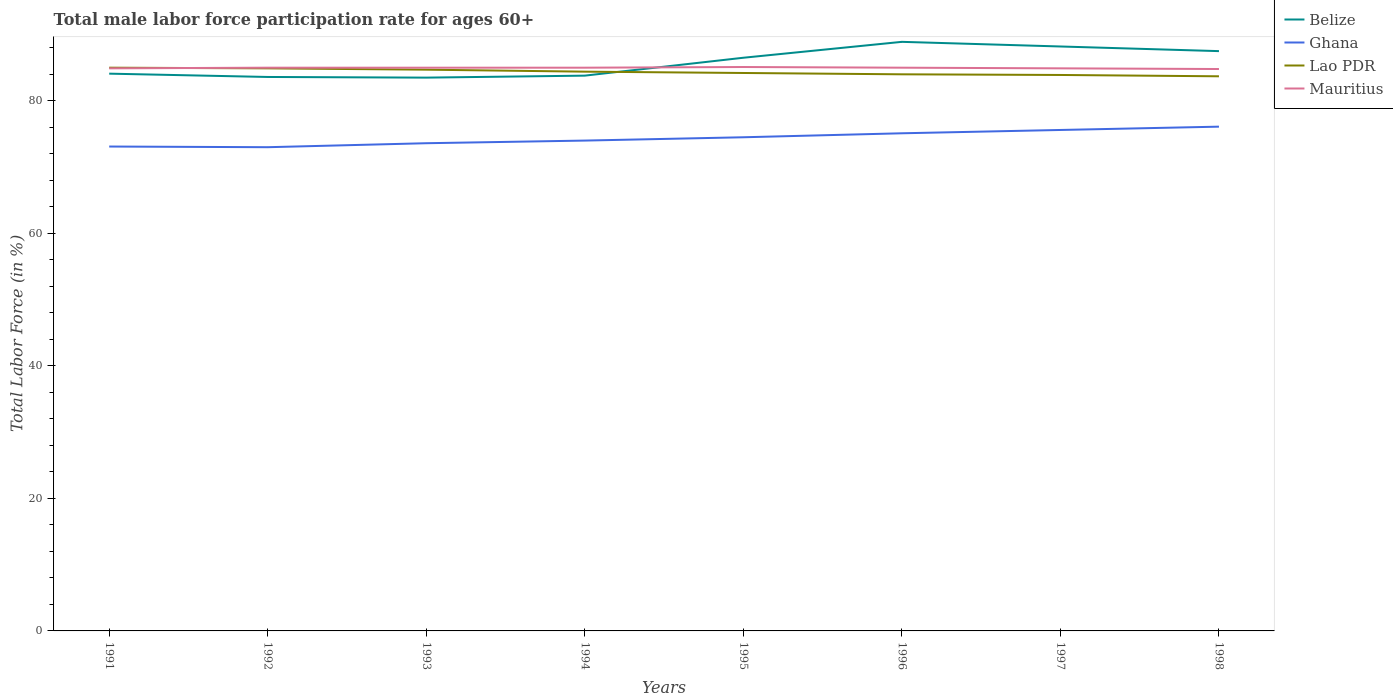Is the number of lines equal to the number of legend labels?
Your answer should be compact. Yes. Across all years, what is the maximum male labor force participation rate in Belize?
Make the answer very short. 83.5. What is the total male labor force participation rate in Ghana in the graph?
Provide a succinct answer. -2.5. What is the difference between the highest and the second highest male labor force participation rate in Ghana?
Make the answer very short. 3.1. Is the male labor force participation rate in Mauritius strictly greater than the male labor force participation rate in Ghana over the years?
Offer a terse response. No. How many years are there in the graph?
Ensure brevity in your answer.  8. What is the difference between two consecutive major ticks on the Y-axis?
Provide a succinct answer. 20. Are the values on the major ticks of Y-axis written in scientific E-notation?
Provide a short and direct response. No. Where does the legend appear in the graph?
Keep it short and to the point. Top right. How many legend labels are there?
Your answer should be compact. 4. How are the legend labels stacked?
Your answer should be very brief. Vertical. What is the title of the graph?
Provide a succinct answer. Total male labor force participation rate for ages 60+. What is the label or title of the X-axis?
Provide a succinct answer. Years. What is the label or title of the Y-axis?
Your answer should be very brief. Total Labor Force (in %). What is the Total Labor Force (in %) in Belize in 1991?
Your answer should be compact. 84.1. What is the Total Labor Force (in %) of Ghana in 1991?
Offer a very short reply. 73.1. What is the Total Labor Force (in %) in Mauritius in 1991?
Make the answer very short. 84.9. What is the Total Labor Force (in %) in Belize in 1992?
Keep it short and to the point. 83.6. What is the Total Labor Force (in %) in Ghana in 1992?
Your answer should be very brief. 73. What is the Total Labor Force (in %) in Lao PDR in 1992?
Give a very brief answer. 84.9. What is the Total Labor Force (in %) of Mauritius in 1992?
Keep it short and to the point. 85. What is the Total Labor Force (in %) of Belize in 1993?
Offer a terse response. 83.5. What is the Total Labor Force (in %) in Ghana in 1993?
Keep it short and to the point. 73.6. What is the Total Labor Force (in %) of Lao PDR in 1993?
Give a very brief answer. 84.7. What is the Total Labor Force (in %) of Belize in 1994?
Your response must be concise. 83.8. What is the Total Labor Force (in %) in Ghana in 1994?
Your response must be concise. 74. What is the Total Labor Force (in %) of Lao PDR in 1994?
Your answer should be compact. 84.4. What is the Total Labor Force (in %) of Belize in 1995?
Your answer should be very brief. 86.5. What is the Total Labor Force (in %) of Ghana in 1995?
Offer a very short reply. 74.5. What is the Total Labor Force (in %) of Lao PDR in 1995?
Make the answer very short. 84.2. What is the Total Labor Force (in %) of Mauritius in 1995?
Make the answer very short. 85.1. What is the Total Labor Force (in %) in Belize in 1996?
Your response must be concise. 88.9. What is the Total Labor Force (in %) of Ghana in 1996?
Keep it short and to the point. 75.1. What is the Total Labor Force (in %) of Mauritius in 1996?
Ensure brevity in your answer.  85. What is the Total Labor Force (in %) in Belize in 1997?
Provide a short and direct response. 88.2. What is the Total Labor Force (in %) in Ghana in 1997?
Your response must be concise. 75.6. What is the Total Labor Force (in %) in Lao PDR in 1997?
Give a very brief answer. 83.9. What is the Total Labor Force (in %) in Mauritius in 1997?
Provide a succinct answer. 84.9. What is the Total Labor Force (in %) of Belize in 1998?
Offer a terse response. 87.5. What is the Total Labor Force (in %) in Ghana in 1998?
Ensure brevity in your answer.  76.1. What is the Total Labor Force (in %) in Lao PDR in 1998?
Give a very brief answer. 83.7. What is the Total Labor Force (in %) of Mauritius in 1998?
Your response must be concise. 84.8. Across all years, what is the maximum Total Labor Force (in %) of Belize?
Provide a short and direct response. 88.9. Across all years, what is the maximum Total Labor Force (in %) in Ghana?
Provide a short and direct response. 76.1. Across all years, what is the maximum Total Labor Force (in %) of Mauritius?
Your answer should be very brief. 85.1. Across all years, what is the minimum Total Labor Force (in %) of Belize?
Your response must be concise. 83.5. Across all years, what is the minimum Total Labor Force (in %) in Lao PDR?
Offer a terse response. 83.7. Across all years, what is the minimum Total Labor Force (in %) of Mauritius?
Ensure brevity in your answer.  84.8. What is the total Total Labor Force (in %) in Belize in the graph?
Offer a terse response. 686.1. What is the total Total Labor Force (in %) in Ghana in the graph?
Provide a short and direct response. 595. What is the total Total Labor Force (in %) in Lao PDR in the graph?
Your answer should be compact. 674.8. What is the total Total Labor Force (in %) in Mauritius in the graph?
Provide a short and direct response. 679.7. What is the difference between the Total Labor Force (in %) of Belize in 1991 and that in 1992?
Keep it short and to the point. 0.5. What is the difference between the Total Labor Force (in %) of Ghana in 1991 and that in 1992?
Ensure brevity in your answer.  0.1. What is the difference between the Total Labor Force (in %) in Lao PDR in 1991 and that in 1992?
Offer a very short reply. 0.1. What is the difference between the Total Labor Force (in %) in Mauritius in 1991 and that in 1993?
Make the answer very short. -0.1. What is the difference between the Total Labor Force (in %) of Belize in 1991 and that in 1994?
Ensure brevity in your answer.  0.3. What is the difference between the Total Labor Force (in %) of Ghana in 1991 and that in 1994?
Give a very brief answer. -0.9. What is the difference between the Total Labor Force (in %) in Lao PDR in 1991 and that in 1994?
Your answer should be compact. 0.6. What is the difference between the Total Labor Force (in %) of Mauritius in 1991 and that in 1994?
Your answer should be very brief. -0.1. What is the difference between the Total Labor Force (in %) in Belize in 1991 and that in 1995?
Keep it short and to the point. -2.4. What is the difference between the Total Labor Force (in %) in Ghana in 1991 and that in 1995?
Give a very brief answer. -1.4. What is the difference between the Total Labor Force (in %) of Lao PDR in 1991 and that in 1995?
Your answer should be compact. 0.8. What is the difference between the Total Labor Force (in %) in Belize in 1991 and that in 1996?
Make the answer very short. -4.8. What is the difference between the Total Labor Force (in %) in Mauritius in 1991 and that in 1996?
Your answer should be compact. -0.1. What is the difference between the Total Labor Force (in %) of Ghana in 1991 and that in 1997?
Offer a very short reply. -2.5. What is the difference between the Total Labor Force (in %) in Lao PDR in 1991 and that in 1997?
Keep it short and to the point. 1.1. What is the difference between the Total Labor Force (in %) in Mauritius in 1991 and that in 1997?
Your answer should be compact. 0. What is the difference between the Total Labor Force (in %) of Belize in 1991 and that in 1998?
Ensure brevity in your answer.  -3.4. What is the difference between the Total Labor Force (in %) of Ghana in 1991 and that in 1998?
Your answer should be compact. -3. What is the difference between the Total Labor Force (in %) in Mauritius in 1991 and that in 1998?
Your answer should be compact. 0.1. What is the difference between the Total Labor Force (in %) of Belize in 1992 and that in 1993?
Provide a succinct answer. 0.1. What is the difference between the Total Labor Force (in %) in Mauritius in 1992 and that in 1993?
Ensure brevity in your answer.  0. What is the difference between the Total Labor Force (in %) in Belize in 1992 and that in 1994?
Provide a succinct answer. -0.2. What is the difference between the Total Labor Force (in %) of Lao PDR in 1992 and that in 1994?
Your response must be concise. 0.5. What is the difference between the Total Labor Force (in %) of Mauritius in 1992 and that in 1994?
Your answer should be compact. 0. What is the difference between the Total Labor Force (in %) in Belize in 1992 and that in 1995?
Provide a succinct answer. -2.9. What is the difference between the Total Labor Force (in %) in Ghana in 1992 and that in 1995?
Offer a terse response. -1.5. What is the difference between the Total Labor Force (in %) of Lao PDR in 1992 and that in 1995?
Your answer should be compact. 0.7. What is the difference between the Total Labor Force (in %) in Ghana in 1992 and that in 1996?
Ensure brevity in your answer.  -2.1. What is the difference between the Total Labor Force (in %) in Mauritius in 1992 and that in 1996?
Ensure brevity in your answer.  0. What is the difference between the Total Labor Force (in %) in Ghana in 1992 and that in 1997?
Ensure brevity in your answer.  -2.6. What is the difference between the Total Labor Force (in %) of Mauritius in 1992 and that in 1997?
Make the answer very short. 0.1. What is the difference between the Total Labor Force (in %) in Lao PDR in 1992 and that in 1998?
Your response must be concise. 1.2. What is the difference between the Total Labor Force (in %) of Mauritius in 1992 and that in 1998?
Provide a succinct answer. 0.2. What is the difference between the Total Labor Force (in %) in Belize in 1993 and that in 1994?
Keep it short and to the point. -0.3. What is the difference between the Total Labor Force (in %) in Lao PDR in 1993 and that in 1994?
Give a very brief answer. 0.3. What is the difference between the Total Labor Force (in %) in Belize in 1993 and that in 1996?
Your response must be concise. -5.4. What is the difference between the Total Labor Force (in %) in Mauritius in 1993 and that in 1996?
Keep it short and to the point. 0. What is the difference between the Total Labor Force (in %) of Mauritius in 1993 and that in 1997?
Make the answer very short. 0.1. What is the difference between the Total Labor Force (in %) in Belize in 1993 and that in 1998?
Give a very brief answer. -4. What is the difference between the Total Labor Force (in %) of Mauritius in 1993 and that in 1998?
Your answer should be compact. 0.2. What is the difference between the Total Labor Force (in %) of Ghana in 1994 and that in 1995?
Make the answer very short. -0.5. What is the difference between the Total Labor Force (in %) of Lao PDR in 1994 and that in 1995?
Offer a very short reply. 0.2. What is the difference between the Total Labor Force (in %) of Lao PDR in 1994 and that in 1996?
Make the answer very short. 0.4. What is the difference between the Total Labor Force (in %) in Belize in 1994 and that in 1997?
Keep it short and to the point. -4.4. What is the difference between the Total Labor Force (in %) in Ghana in 1994 and that in 1997?
Offer a very short reply. -1.6. What is the difference between the Total Labor Force (in %) in Mauritius in 1994 and that in 1997?
Your answer should be compact. 0.1. What is the difference between the Total Labor Force (in %) of Belize in 1994 and that in 1998?
Your answer should be compact. -3.7. What is the difference between the Total Labor Force (in %) in Ghana in 1994 and that in 1998?
Provide a short and direct response. -2.1. What is the difference between the Total Labor Force (in %) in Lao PDR in 1994 and that in 1998?
Provide a succinct answer. 0.7. What is the difference between the Total Labor Force (in %) of Belize in 1995 and that in 1996?
Your answer should be very brief. -2.4. What is the difference between the Total Labor Force (in %) of Ghana in 1995 and that in 1996?
Offer a terse response. -0.6. What is the difference between the Total Labor Force (in %) in Lao PDR in 1995 and that in 1996?
Make the answer very short. 0.2. What is the difference between the Total Labor Force (in %) in Mauritius in 1995 and that in 1996?
Ensure brevity in your answer.  0.1. What is the difference between the Total Labor Force (in %) in Lao PDR in 1995 and that in 1997?
Ensure brevity in your answer.  0.3. What is the difference between the Total Labor Force (in %) in Mauritius in 1995 and that in 1997?
Your answer should be compact. 0.2. What is the difference between the Total Labor Force (in %) in Mauritius in 1995 and that in 1998?
Give a very brief answer. 0.3. What is the difference between the Total Labor Force (in %) in Ghana in 1996 and that in 1998?
Your answer should be compact. -1. What is the difference between the Total Labor Force (in %) in Lao PDR in 1996 and that in 1998?
Give a very brief answer. 0.3. What is the difference between the Total Labor Force (in %) of Ghana in 1997 and that in 1998?
Your answer should be very brief. -0.5. What is the difference between the Total Labor Force (in %) in Lao PDR in 1997 and that in 1998?
Provide a short and direct response. 0.2. What is the difference between the Total Labor Force (in %) in Belize in 1991 and the Total Labor Force (in %) in Ghana in 1992?
Keep it short and to the point. 11.1. What is the difference between the Total Labor Force (in %) in Belize in 1991 and the Total Labor Force (in %) in Lao PDR in 1992?
Offer a terse response. -0.8. What is the difference between the Total Labor Force (in %) in Ghana in 1991 and the Total Labor Force (in %) in Lao PDR in 1992?
Make the answer very short. -11.8. What is the difference between the Total Labor Force (in %) in Belize in 1991 and the Total Labor Force (in %) in Ghana in 1993?
Your response must be concise. 10.5. What is the difference between the Total Labor Force (in %) of Ghana in 1991 and the Total Labor Force (in %) of Lao PDR in 1993?
Provide a succinct answer. -11.6. What is the difference between the Total Labor Force (in %) of Ghana in 1991 and the Total Labor Force (in %) of Mauritius in 1993?
Your answer should be very brief. -11.9. What is the difference between the Total Labor Force (in %) in Lao PDR in 1991 and the Total Labor Force (in %) in Mauritius in 1993?
Your answer should be compact. 0. What is the difference between the Total Labor Force (in %) in Belize in 1991 and the Total Labor Force (in %) in Lao PDR in 1994?
Give a very brief answer. -0.3. What is the difference between the Total Labor Force (in %) of Ghana in 1991 and the Total Labor Force (in %) of Lao PDR in 1994?
Keep it short and to the point. -11.3. What is the difference between the Total Labor Force (in %) of Ghana in 1991 and the Total Labor Force (in %) of Mauritius in 1994?
Provide a succinct answer. -11.9. What is the difference between the Total Labor Force (in %) of Belize in 1991 and the Total Labor Force (in %) of Lao PDR in 1995?
Offer a very short reply. -0.1. What is the difference between the Total Labor Force (in %) of Belize in 1991 and the Total Labor Force (in %) of Mauritius in 1995?
Keep it short and to the point. -1. What is the difference between the Total Labor Force (in %) of Ghana in 1991 and the Total Labor Force (in %) of Lao PDR in 1995?
Offer a very short reply. -11.1. What is the difference between the Total Labor Force (in %) of Lao PDR in 1991 and the Total Labor Force (in %) of Mauritius in 1995?
Provide a short and direct response. -0.1. What is the difference between the Total Labor Force (in %) of Belize in 1991 and the Total Labor Force (in %) of Ghana in 1996?
Give a very brief answer. 9. What is the difference between the Total Labor Force (in %) in Ghana in 1991 and the Total Labor Force (in %) in Lao PDR in 1996?
Make the answer very short. -10.9. What is the difference between the Total Labor Force (in %) in Lao PDR in 1991 and the Total Labor Force (in %) in Mauritius in 1996?
Ensure brevity in your answer.  0. What is the difference between the Total Labor Force (in %) in Belize in 1991 and the Total Labor Force (in %) in Lao PDR in 1997?
Your response must be concise. 0.2. What is the difference between the Total Labor Force (in %) in Ghana in 1991 and the Total Labor Force (in %) in Lao PDR in 1997?
Give a very brief answer. -10.8. What is the difference between the Total Labor Force (in %) of Ghana in 1991 and the Total Labor Force (in %) of Mauritius in 1997?
Offer a very short reply. -11.8. What is the difference between the Total Labor Force (in %) of Belize in 1991 and the Total Labor Force (in %) of Lao PDR in 1998?
Make the answer very short. 0.4. What is the difference between the Total Labor Force (in %) of Lao PDR in 1991 and the Total Labor Force (in %) of Mauritius in 1998?
Give a very brief answer. 0.2. What is the difference between the Total Labor Force (in %) of Belize in 1992 and the Total Labor Force (in %) of Lao PDR in 1993?
Your answer should be compact. -1.1. What is the difference between the Total Labor Force (in %) in Belize in 1992 and the Total Labor Force (in %) in Mauritius in 1993?
Provide a succinct answer. -1.4. What is the difference between the Total Labor Force (in %) of Ghana in 1992 and the Total Labor Force (in %) of Lao PDR in 1993?
Ensure brevity in your answer.  -11.7. What is the difference between the Total Labor Force (in %) in Lao PDR in 1992 and the Total Labor Force (in %) in Mauritius in 1993?
Keep it short and to the point. -0.1. What is the difference between the Total Labor Force (in %) of Belize in 1992 and the Total Labor Force (in %) of Ghana in 1994?
Keep it short and to the point. 9.6. What is the difference between the Total Labor Force (in %) in Belize in 1992 and the Total Labor Force (in %) in Mauritius in 1994?
Give a very brief answer. -1.4. What is the difference between the Total Labor Force (in %) in Ghana in 1992 and the Total Labor Force (in %) in Lao PDR in 1994?
Offer a very short reply. -11.4. What is the difference between the Total Labor Force (in %) of Ghana in 1992 and the Total Labor Force (in %) of Mauritius in 1994?
Your response must be concise. -12. What is the difference between the Total Labor Force (in %) of Lao PDR in 1992 and the Total Labor Force (in %) of Mauritius in 1994?
Ensure brevity in your answer.  -0.1. What is the difference between the Total Labor Force (in %) in Belize in 1992 and the Total Labor Force (in %) in Ghana in 1995?
Offer a terse response. 9.1. What is the difference between the Total Labor Force (in %) in Belize in 1992 and the Total Labor Force (in %) in Mauritius in 1995?
Provide a succinct answer. -1.5. What is the difference between the Total Labor Force (in %) in Ghana in 1992 and the Total Labor Force (in %) in Mauritius in 1995?
Offer a very short reply. -12.1. What is the difference between the Total Labor Force (in %) in Lao PDR in 1992 and the Total Labor Force (in %) in Mauritius in 1995?
Offer a terse response. -0.2. What is the difference between the Total Labor Force (in %) of Lao PDR in 1992 and the Total Labor Force (in %) of Mauritius in 1996?
Keep it short and to the point. -0.1. What is the difference between the Total Labor Force (in %) in Belize in 1992 and the Total Labor Force (in %) in Ghana in 1997?
Your response must be concise. 8. What is the difference between the Total Labor Force (in %) of Belize in 1992 and the Total Labor Force (in %) of Lao PDR in 1997?
Offer a terse response. -0.3. What is the difference between the Total Labor Force (in %) in Belize in 1992 and the Total Labor Force (in %) in Mauritius in 1997?
Offer a very short reply. -1.3. What is the difference between the Total Labor Force (in %) of Ghana in 1992 and the Total Labor Force (in %) of Lao PDR in 1997?
Keep it short and to the point. -10.9. What is the difference between the Total Labor Force (in %) of Lao PDR in 1992 and the Total Labor Force (in %) of Mauritius in 1997?
Make the answer very short. 0. What is the difference between the Total Labor Force (in %) in Belize in 1992 and the Total Labor Force (in %) in Mauritius in 1998?
Provide a short and direct response. -1.2. What is the difference between the Total Labor Force (in %) in Belize in 1993 and the Total Labor Force (in %) in Ghana in 1994?
Give a very brief answer. 9.5. What is the difference between the Total Labor Force (in %) of Belize in 1993 and the Total Labor Force (in %) of Lao PDR in 1995?
Offer a very short reply. -0.7. What is the difference between the Total Labor Force (in %) in Belize in 1993 and the Total Labor Force (in %) in Lao PDR in 1996?
Offer a very short reply. -0.5. What is the difference between the Total Labor Force (in %) in Belize in 1993 and the Total Labor Force (in %) in Mauritius in 1996?
Provide a succinct answer. -1.5. What is the difference between the Total Labor Force (in %) in Ghana in 1993 and the Total Labor Force (in %) in Lao PDR in 1996?
Your answer should be very brief. -10.4. What is the difference between the Total Labor Force (in %) in Ghana in 1993 and the Total Labor Force (in %) in Mauritius in 1996?
Your response must be concise. -11.4. What is the difference between the Total Labor Force (in %) in Lao PDR in 1993 and the Total Labor Force (in %) in Mauritius in 1996?
Your response must be concise. -0.3. What is the difference between the Total Labor Force (in %) in Belize in 1993 and the Total Labor Force (in %) in Ghana in 1997?
Give a very brief answer. 7.9. What is the difference between the Total Labor Force (in %) in Belize in 1993 and the Total Labor Force (in %) in Lao PDR in 1998?
Make the answer very short. -0.2. What is the difference between the Total Labor Force (in %) of Ghana in 1993 and the Total Labor Force (in %) of Lao PDR in 1998?
Your response must be concise. -10.1. What is the difference between the Total Labor Force (in %) in Belize in 1994 and the Total Labor Force (in %) in Lao PDR in 1995?
Your response must be concise. -0.4. What is the difference between the Total Labor Force (in %) in Belize in 1994 and the Total Labor Force (in %) in Mauritius in 1995?
Your answer should be compact. -1.3. What is the difference between the Total Labor Force (in %) of Lao PDR in 1994 and the Total Labor Force (in %) of Mauritius in 1995?
Give a very brief answer. -0.7. What is the difference between the Total Labor Force (in %) in Belize in 1994 and the Total Labor Force (in %) in Ghana in 1996?
Offer a very short reply. 8.7. What is the difference between the Total Labor Force (in %) of Belize in 1994 and the Total Labor Force (in %) of Lao PDR in 1996?
Your answer should be very brief. -0.2. What is the difference between the Total Labor Force (in %) in Ghana in 1994 and the Total Labor Force (in %) in Mauritius in 1996?
Give a very brief answer. -11. What is the difference between the Total Labor Force (in %) in Belize in 1994 and the Total Labor Force (in %) in Lao PDR in 1997?
Provide a succinct answer. -0.1. What is the difference between the Total Labor Force (in %) of Ghana in 1994 and the Total Labor Force (in %) of Mauritius in 1997?
Give a very brief answer. -10.9. What is the difference between the Total Labor Force (in %) of Lao PDR in 1994 and the Total Labor Force (in %) of Mauritius in 1997?
Your answer should be very brief. -0.5. What is the difference between the Total Labor Force (in %) of Belize in 1994 and the Total Labor Force (in %) of Ghana in 1998?
Your response must be concise. 7.7. What is the difference between the Total Labor Force (in %) in Belize in 1994 and the Total Labor Force (in %) in Lao PDR in 1998?
Make the answer very short. 0.1. What is the difference between the Total Labor Force (in %) in Ghana in 1994 and the Total Labor Force (in %) in Lao PDR in 1998?
Make the answer very short. -9.7. What is the difference between the Total Labor Force (in %) in Belize in 1995 and the Total Labor Force (in %) in Lao PDR in 1996?
Your answer should be compact. 2.5. What is the difference between the Total Labor Force (in %) in Ghana in 1995 and the Total Labor Force (in %) in Lao PDR in 1996?
Make the answer very short. -9.5. What is the difference between the Total Labor Force (in %) in Ghana in 1995 and the Total Labor Force (in %) in Mauritius in 1996?
Your answer should be very brief. -10.5. What is the difference between the Total Labor Force (in %) in Lao PDR in 1995 and the Total Labor Force (in %) in Mauritius in 1996?
Make the answer very short. -0.8. What is the difference between the Total Labor Force (in %) of Ghana in 1995 and the Total Labor Force (in %) of Lao PDR in 1997?
Your response must be concise. -9.4. What is the difference between the Total Labor Force (in %) in Ghana in 1995 and the Total Labor Force (in %) in Mauritius in 1997?
Your answer should be very brief. -10.4. What is the difference between the Total Labor Force (in %) of Lao PDR in 1995 and the Total Labor Force (in %) of Mauritius in 1997?
Provide a succinct answer. -0.7. What is the difference between the Total Labor Force (in %) of Belize in 1995 and the Total Labor Force (in %) of Ghana in 1998?
Provide a succinct answer. 10.4. What is the difference between the Total Labor Force (in %) of Belize in 1995 and the Total Labor Force (in %) of Lao PDR in 1998?
Provide a succinct answer. 2.8. What is the difference between the Total Labor Force (in %) of Ghana in 1995 and the Total Labor Force (in %) of Lao PDR in 1998?
Your response must be concise. -9.2. What is the difference between the Total Labor Force (in %) in Ghana in 1995 and the Total Labor Force (in %) in Mauritius in 1998?
Give a very brief answer. -10.3. What is the difference between the Total Labor Force (in %) of Lao PDR in 1995 and the Total Labor Force (in %) of Mauritius in 1998?
Give a very brief answer. -0.6. What is the difference between the Total Labor Force (in %) of Ghana in 1996 and the Total Labor Force (in %) of Lao PDR in 1997?
Offer a very short reply. -8.8. What is the difference between the Total Labor Force (in %) of Ghana in 1996 and the Total Labor Force (in %) of Mauritius in 1997?
Ensure brevity in your answer.  -9.8. What is the difference between the Total Labor Force (in %) in Ghana in 1996 and the Total Labor Force (in %) in Lao PDR in 1998?
Keep it short and to the point. -8.6. What is the difference between the Total Labor Force (in %) of Ghana in 1996 and the Total Labor Force (in %) of Mauritius in 1998?
Offer a very short reply. -9.7. What is the difference between the Total Labor Force (in %) in Lao PDR in 1996 and the Total Labor Force (in %) in Mauritius in 1998?
Make the answer very short. -0.8. What is the difference between the Total Labor Force (in %) of Belize in 1997 and the Total Labor Force (in %) of Lao PDR in 1998?
Keep it short and to the point. 4.5. What is the difference between the Total Labor Force (in %) in Ghana in 1997 and the Total Labor Force (in %) in Lao PDR in 1998?
Offer a very short reply. -8.1. What is the difference between the Total Labor Force (in %) in Lao PDR in 1997 and the Total Labor Force (in %) in Mauritius in 1998?
Offer a terse response. -0.9. What is the average Total Labor Force (in %) of Belize per year?
Make the answer very short. 85.76. What is the average Total Labor Force (in %) in Ghana per year?
Keep it short and to the point. 74.38. What is the average Total Labor Force (in %) of Lao PDR per year?
Offer a terse response. 84.35. What is the average Total Labor Force (in %) of Mauritius per year?
Your response must be concise. 84.96. In the year 1991, what is the difference between the Total Labor Force (in %) of Belize and Total Labor Force (in %) of Mauritius?
Keep it short and to the point. -0.8. In the year 1991, what is the difference between the Total Labor Force (in %) in Ghana and Total Labor Force (in %) in Lao PDR?
Your answer should be compact. -11.9. In the year 1992, what is the difference between the Total Labor Force (in %) of Belize and Total Labor Force (in %) of Ghana?
Ensure brevity in your answer.  10.6. In the year 1992, what is the difference between the Total Labor Force (in %) of Belize and Total Labor Force (in %) of Lao PDR?
Provide a succinct answer. -1.3. In the year 1992, what is the difference between the Total Labor Force (in %) of Ghana and Total Labor Force (in %) of Lao PDR?
Your response must be concise. -11.9. In the year 1993, what is the difference between the Total Labor Force (in %) of Belize and Total Labor Force (in %) of Lao PDR?
Make the answer very short. -1.2. In the year 1993, what is the difference between the Total Labor Force (in %) of Belize and Total Labor Force (in %) of Mauritius?
Ensure brevity in your answer.  -1.5. In the year 1993, what is the difference between the Total Labor Force (in %) in Ghana and Total Labor Force (in %) in Lao PDR?
Offer a terse response. -11.1. In the year 1994, what is the difference between the Total Labor Force (in %) in Belize and Total Labor Force (in %) in Ghana?
Offer a terse response. 9.8. In the year 1994, what is the difference between the Total Labor Force (in %) in Belize and Total Labor Force (in %) in Lao PDR?
Your answer should be compact. -0.6. In the year 1994, what is the difference between the Total Labor Force (in %) in Ghana and Total Labor Force (in %) in Mauritius?
Offer a very short reply. -11. In the year 1994, what is the difference between the Total Labor Force (in %) in Lao PDR and Total Labor Force (in %) in Mauritius?
Keep it short and to the point. -0.6. In the year 1995, what is the difference between the Total Labor Force (in %) of Lao PDR and Total Labor Force (in %) of Mauritius?
Provide a succinct answer. -0.9. In the year 1996, what is the difference between the Total Labor Force (in %) of Belize and Total Labor Force (in %) of Lao PDR?
Your answer should be very brief. 4.9. In the year 1996, what is the difference between the Total Labor Force (in %) in Lao PDR and Total Labor Force (in %) in Mauritius?
Make the answer very short. -1. In the year 1997, what is the difference between the Total Labor Force (in %) of Belize and Total Labor Force (in %) of Ghana?
Keep it short and to the point. 12.6. In the year 1997, what is the difference between the Total Labor Force (in %) in Belize and Total Labor Force (in %) in Lao PDR?
Your answer should be compact. 4.3. In the year 1997, what is the difference between the Total Labor Force (in %) in Belize and Total Labor Force (in %) in Mauritius?
Your answer should be very brief. 3.3. In the year 1997, what is the difference between the Total Labor Force (in %) of Ghana and Total Labor Force (in %) of Mauritius?
Your answer should be very brief. -9.3. In the year 1997, what is the difference between the Total Labor Force (in %) of Lao PDR and Total Labor Force (in %) of Mauritius?
Ensure brevity in your answer.  -1. In the year 1998, what is the difference between the Total Labor Force (in %) of Ghana and Total Labor Force (in %) of Lao PDR?
Keep it short and to the point. -7.6. What is the ratio of the Total Labor Force (in %) of Ghana in 1991 to that in 1992?
Provide a short and direct response. 1. What is the ratio of the Total Labor Force (in %) of Mauritius in 1991 to that in 1992?
Keep it short and to the point. 1. What is the ratio of the Total Labor Force (in %) of Mauritius in 1991 to that in 1993?
Offer a terse response. 1. What is the ratio of the Total Labor Force (in %) of Belize in 1991 to that in 1994?
Make the answer very short. 1. What is the ratio of the Total Labor Force (in %) in Ghana in 1991 to that in 1994?
Ensure brevity in your answer.  0.99. What is the ratio of the Total Labor Force (in %) of Lao PDR in 1991 to that in 1994?
Provide a short and direct response. 1.01. What is the ratio of the Total Labor Force (in %) in Belize in 1991 to that in 1995?
Your answer should be compact. 0.97. What is the ratio of the Total Labor Force (in %) in Ghana in 1991 to that in 1995?
Provide a short and direct response. 0.98. What is the ratio of the Total Labor Force (in %) in Lao PDR in 1991 to that in 1995?
Provide a succinct answer. 1.01. What is the ratio of the Total Labor Force (in %) of Belize in 1991 to that in 1996?
Offer a very short reply. 0.95. What is the ratio of the Total Labor Force (in %) in Ghana in 1991 to that in 1996?
Offer a very short reply. 0.97. What is the ratio of the Total Labor Force (in %) of Lao PDR in 1991 to that in 1996?
Keep it short and to the point. 1.01. What is the ratio of the Total Labor Force (in %) of Belize in 1991 to that in 1997?
Your answer should be compact. 0.95. What is the ratio of the Total Labor Force (in %) of Ghana in 1991 to that in 1997?
Keep it short and to the point. 0.97. What is the ratio of the Total Labor Force (in %) in Lao PDR in 1991 to that in 1997?
Your answer should be very brief. 1.01. What is the ratio of the Total Labor Force (in %) of Belize in 1991 to that in 1998?
Your answer should be compact. 0.96. What is the ratio of the Total Labor Force (in %) of Ghana in 1991 to that in 1998?
Provide a short and direct response. 0.96. What is the ratio of the Total Labor Force (in %) in Lao PDR in 1991 to that in 1998?
Your response must be concise. 1.02. What is the ratio of the Total Labor Force (in %) of Belize in 1992 to that in 1993?
Offer a very short reply. 1. What is the ratio of the Total Labor Force (in %) of Ghana in 1992 to that in 1993?
Provide a succinct answer. 0.99. What is the ratio of the Total Labor Force (in %) of Belize in 1992 to that in 1994?
Make the answer very short. 1. What is the ratio of the Total Labor Force (in %) in Ghana in 1992 to that in 1994?
Give a very brief answer. 0.99. What is the ratio of the Total Labor Force (in %) in Lao PDR in 1992 to that in 1994?
Provide a succinct answer. 1.01. What is the ratio of the Total Labor Force (in %) in Mauritius in 1992 to that in 1994?
Provide a succinct answer. 1. What is the ratio of the Total Labor Force (in %) of Belize in 1992 to that in 1995?
Offer a terse response. 0.97. What is the ratio of the Total Labor Force (in %) in Ghana in 1992 to that in 1995?
Make the answer very short. 0.98. What is the ratio of the Total Labor Force (in %) in Lao PDR in 1992 to that in 1995?
Keep it short and to the point. 1.01. What is the ratio of the Total Labor Force (in %) in Mauritius in 1992 to that in 1995?
Your answer should be very brief. 1. What is the ratio of the Total Labor Force (in %) of Belize in 1992 to that in 1996?
Provide a succinct answer. 0.94. What is the ratio of the Total Labor Force (in %) of Ghana in 1992 to that in 1996?
Keep it short and to the point. 0.97. What is the ratio of the Total Labor Force (in %) in Lao PDR in 1992 to that in 1996?
Keep it short and to the point. 1.01. What is the ratio of the Total Labor Force (in %) of Mauritius in 1992 to that in 1996?
Your answer should be compact. 1. What is the ratio of the Total Labor Force (in %) in Belize in 1992 to that in 1997?
Ensure brevity in your answer.  0.95. What is the ratio of the Total Labor Force (in %) of Ghana in 1992 to that in 1997?
Give a very brief answer. 0.97. What is the ratio of the Total Labor Force (in %) in Lao PDR in 1992 to that in 1997?
Your answer should be very brief. 1.01. What is the ratio of the Total Labor Force (in %) of Belize in 1992 to that in 1998?
Make the answer very short. 0.96. What is the ratio of the Total Labor Force (in %) in Ghana in 1992 to that in 1998?
Your response must be concise. 0.96. What is the ratio of the Total Labor Force (in %) of Lao PDR in 1992 to that in 1998?
Offer a terse response. 1.01. What is the ratio of the Total Labor Force (in %) in Belize in 1993 to that in 1994?
Ensure brevity in your answer.  1. What is the ratio of the Total Labor Force (in %) of Ghana in 1993 to that in 1994?
Provide a succinct answer. 0.99. What is the ratio of the Total Labor Force (in %) in Belize in 1993 to that in 1995?
Your response must be concise. 0.97. What is the ratio of the Total Labor Force (in %) in Ghana in 1993 to that in 1995?
Your response must be concise. 0.99. What is the ratio of the Total Labor Force (in %) of Lao PDR in 1993 to that in 1995?
Provide a short and direct response. 1.01. What is the ratio of the Total Labor Force (in %) of Belize in 1993 to that in 1996?
Give a very brief answer. 0.94. What is the ratio of the Total Labor Force (in %) in Lao PDR in 1993 to that in 1996?
Offer a terse response. 1.01. What is the ratio of the Total Labor Force (in %) of Mauritius in 1993 to that in 1996?
Offer a terse response. 1. What is the ratio of the Total Labor Force (in %) in Belize in 1993 to that in 1997?
Your response must be concise. 0.95. What is the ratio of the Total Labor Force (in %) in Ghana in 1993 to that in 1997?
Your answer should be very brief. 0.97. What is the ratio of the Total Labor Force (in %) in Lao PDR in 1993 to that in 1997?
Your answer should be very brief. 1.01. What is the ratio of the Total Labor Force (in %) in Mauritius in 1993 to that in 1997?
Keep it short and to the point. 1. What is the ratio of the Total Labor Force (in %) in Belize in 1993 to that in 1998?
Provide a short and direct response. 0.95. What is the ratio of the Total Labor Force (in %) in Ghana in 1993 to that in 1998?
Offer a very short reply. 0.97. What is the ratio of the Total Labor Force (in %) of Lao PDR in 1993 to that in 1998?
Your answer should be compact. 1.01. What is the ratio of the Total Labor Force (in %) in Mauritius in 1993 to that in 1998?
Your response must be concise. 1. What is the ratio of the Total Labor Force (in %) of Belize in 1994 to that in 1995?
Make the answer very short. 0.97. What is the ratio of the Total Labor Force (in %) of Belize in 1994 to that in 1996?
Ensure brevity in your answer.  0.94. What is the ratio of the Total Labor Force (in %) in Ghana in 1994 to that in 1996?
Provide a succinct answer. 0.99. What is the ratio of the Total Labor Force (in %) in Mauritius in 1994 to that in 1996?
Offer a very short reply. 1. What is the ratio of the Total Labor Force (in %) of Belize in 1994 to that in 1997?
Ensure brevity in your answer.  0.95. What is the ratio of the Total Labor Force (in %) of Ghana in 1994 to that in 1997?
Provide a short and direct response. 0.98. What is the ratio of the Total Labor Force (in %) in Lao PDR in 1994 to that in 1997?
Make the answer very short. 1.01. What is the ratio of the Total Labor Force (in %) of Belize in 1994 to that in 1998?
Make the answer very short. 0.96. What is the ratio of the Total Labor Force (in %) in Ghana in 1994 to that in 1998?
Offer a very short reply. 0.97. What is the ratio of the Total Labor Force (in %) in Lao PDR in 1994 to that in 1998?
Your response must be concise. 1.01. What is the ratio of the Total Labor Force (in %) of Ghana in 1995 to that in 1996?
Provide a succinct answer. 0.99. What is the ratio of the Total Labor Force (in %) in Mauritius in 1995 to that in 1996?
Offer a very short reply. 1. What is the ratio of the Total Labor Force (in %) of Belize in 1995 to that in 1997?
Give a very brief answer. 0.98. What is the ratio of the Total Labor Force (in %) of Ghana in 1995 to that in 1997?
Provide a succinct answer. 0.99. What is the ratio of the Total Labor Force (in %) of Lao PDR in 1995 to that in 1997?
Offer a very short reply. 1. What is the ratio of the Total Labor Force (in %) of Mauritius in 1995 to that in 1997?
Keep it short and to the point. 1. What is the ratio of the Total Labor Force (in %) in Belize in 1996 to that in 1997?
Your answer should be compact. 1.01. What is the ratio of the Total Labor Force (in %) in Lao PDR in 1996 to that in 1997?
Offer a terse response. 1. What is the ratio of the Total Labor Force (in %) of Mauritius in 1996 to that in 1997?
Offer a terse response. 1. What is the ratio of the Total Labor Force (in %) of Belize in 1996 to that in 1998?
Keep it short and to the point. 1.02. What is the ratio of the Total Labor Force (in %) in Ghana in 1996 to that in 1998?
Make the answer very short. 0.99. What is the ratio of the Total Labor Force (in %) of Ghana in 1997 to that in 1998?
Your answer should be very brief. 0.99. What is the ratio of the Total Labor Force (in %) of Mauritius in 1997 to that in 1998?
Ensure brevity in your answer.  1. What is the difference between the highest and the second highest Total Labor Force (in %) of Belize?
Make the answer very short. 0.7. What is the difference between the highest and the second highest Total Labor Force (in %) of Lao PDR?
Your answer should be very brief. 0.1. What is the difference between the highest and the lowest Total Labor Force (in %) of Belize?
Your answer should be very brief. 5.4. What is the difference between the highest and the lowest Total Labor Force (in %) in Ghana?
Ensure brevity in your answer.  3.1. 